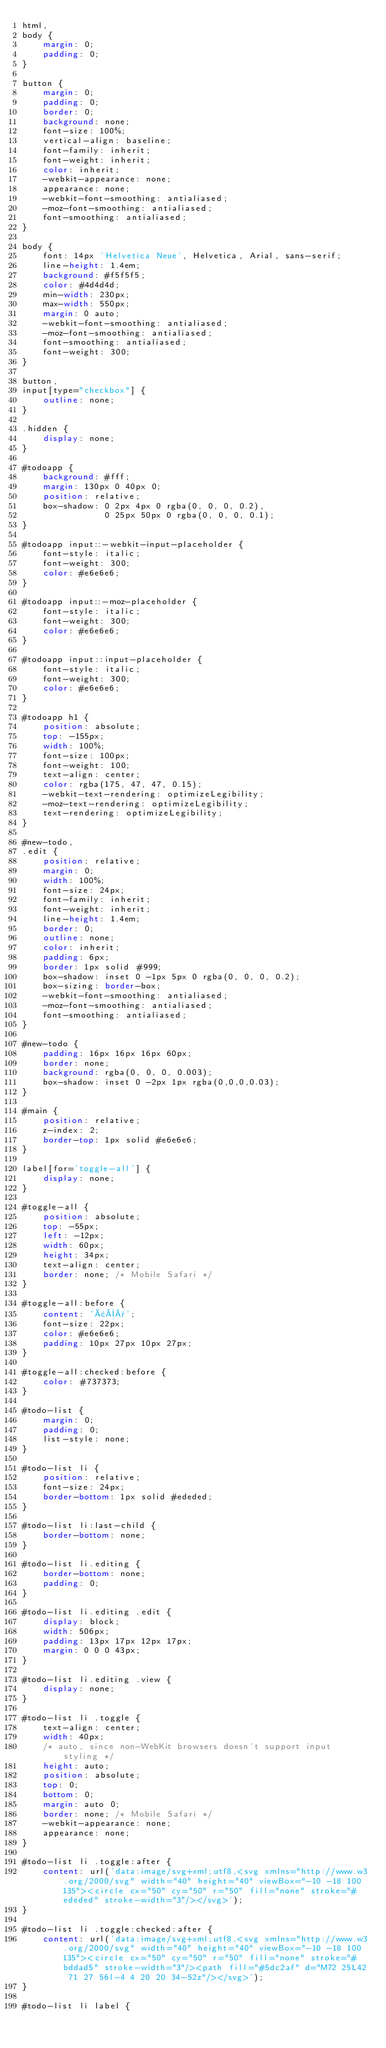<code> <loc_0><loc_0><loc_500><loc_500><_CSS_>html,
body {
	margin: 0;
	padding: 0;
}

button {
	margin: 0;
	padding: 0;
	border: 0;
	background: none;
	font-size: 100%;
	vertical-align: baseline;
	font-family: inherit;
	font-weight: inherit;
	color: inherit;
	-webkit-appearance: none;
	appearance: none;
	-webkit-font-smoothing: antialiased;
	-moz-font-smoothing: antialiased;
	font-smoothing: antialiased;
}

body {
	font: 14px 'Helvetica Neue', Helvetica, Arial, sans-serif;
	line-height: 1.4em;
	background: #f5f5f5;
	color: #4d4d4d;
	min-width: 230px;
	max-width: 550px;
	margin: 0 auto;
	-webkit-font-smoothing: antialiased;
	-moz-font-smoothing: antialiased;
	font-smoothing: antialiased;
	font-weight: 300;
}

button,
input[type="checkbox"] {
	outline: none;
}

.hidden {
	display: none;
}

#todoapp {
	background: #fff;
	margin: 130px 0 40px 0;
	position: relative;
	box-shadow: 0 2px 4px 0 rgba(0, 0, 0, 0.2),
	            0 25px 50px 0 rgba(0, 0, 0, 0.1);
}

#todoapp input::-webkit-input-placeholder {
	font-style: italic;
	font-weight: 300;
	color: #e6e6e6;
}

#todoapp input::-moz-placeholder {
	font-style: italic;
	font-weight: 300;
	color: #e6e6e6;
}

#todoapp input::input-placeholder {
	font-style: italic;
	font-weight: 300;
	color: #e6e6e6;
}

#todoapp h1 {
	position: absolute;
	top: -155px;
	width: 100%;
	font-size: 100px;
	font-weight: 100;
	text-align: center;
	color: rgba(175, 47, 47, 0.15);
	-webkit-text-rendering: optimizeLegibility;
	-moz-text-rendering: optimizeLegibility;
	text-rendering: optimizeLegibility;
}

#new-todo,
.edit {
	position: relative;
	margin: 0;
	width: 100%;
	font-size: 24px;
	font-family: inherit;
	font-weight: inherit;
	line-height: 1.4em;
	border: 0;
	outline: none;
	color: inherit;
	padding: 6px;
	border: 1px solid #999;
	box-shadow: inset 0 -1px 5px 0 rgba(0, 0, 0, 0.2);
	box-sizing: border-box;
	-webkit-font-smoothing: antialiased;
	-moz-font-smoothing: antialiased;
	font-smoothing: antialiased;
}

#new-todo {
	padding: 16px 16px 16px 60px;
	border: none;
	background: rgba(0, 0, 0, 0.003);
	box-shadow: inset 0 -2px 1px rgba(0,0,0,0.03);
}

#main {
	position: relative;
	z-index: 2;
	border-top: 1px solid #e6e6e6;
}

label[for='toggle-all'] {
	display: none;
}

#toggle-all {
	position: absolute;
	top: -55px;
	left: -12px;
	width: 60px;
	height: 34px;
	text-align: center;
	border: none; /* Mobile Safari */
}

#toggle-all:before {
	content: 'â¯';
	font-size: 22px;
	color: #e6e6e6;
	padding: 10px 27px 10px 27px;
}

#toggle-all:checked:before {
	color: #737373;
}

#todo-list {
	margin: 0;
	padding: 0;
	list-style: none;
}

#todo-list li {
	position: relative;
	font-size: 24px;
	border-bottom: 1px solid #ededed;
}

#todo-list li:last-child {
	border-bottom: none;
}

#todo-list li.editing {
	border-bottom: none;
	padding: 0;
}

#todo-list li.editing .edit {
	display: block;
	width: 506px;
	padding: 13px 17px 12px 17px;
	margin: 0 0 0 43px;
}

#todo-list li.editing .view {
	display: none;
}

#todo-list li .toggle {
	text-align: center;
	width: 40px;
	/* auto, since non-WebKit browsers doesn't support input styling */
	height: auto;
	position: absolute;
	top: 0;
	bottom: 0;
	margin: auto 0;
	border: none; /* Mobile Safari */
	-webkit-appearance: none;
	appearance: none;
}

#todo-list li .toggle:after {
	content: url('data:image/svg+xml;utf8,<svg xmlns="http://www.w3.org/2000/svg" width="40" height="40" viewBox="-10 -18 100 135"><circle cx="50" cy="50" r="50" fill="none" stroke="#ededed" stroke-width="3"/></svg>');
}

#todo-list li .toggle:checked:after {
	content: url('data:image/svg+xml;utf8,<svg xmlns="http://www.w3.org/2000/svg" width="40" height="40" viewBox="-10 -18 100 135"><circle cx="50" cy="50" r="50" fill="none" stroke="#bddad5" stroke-width="3"/><path fill="#5dc2af" d="M72 25L42 71 27 56l-4 4 20 20 34-52z"/></svg>');
}

#todo-list li label {</code> 